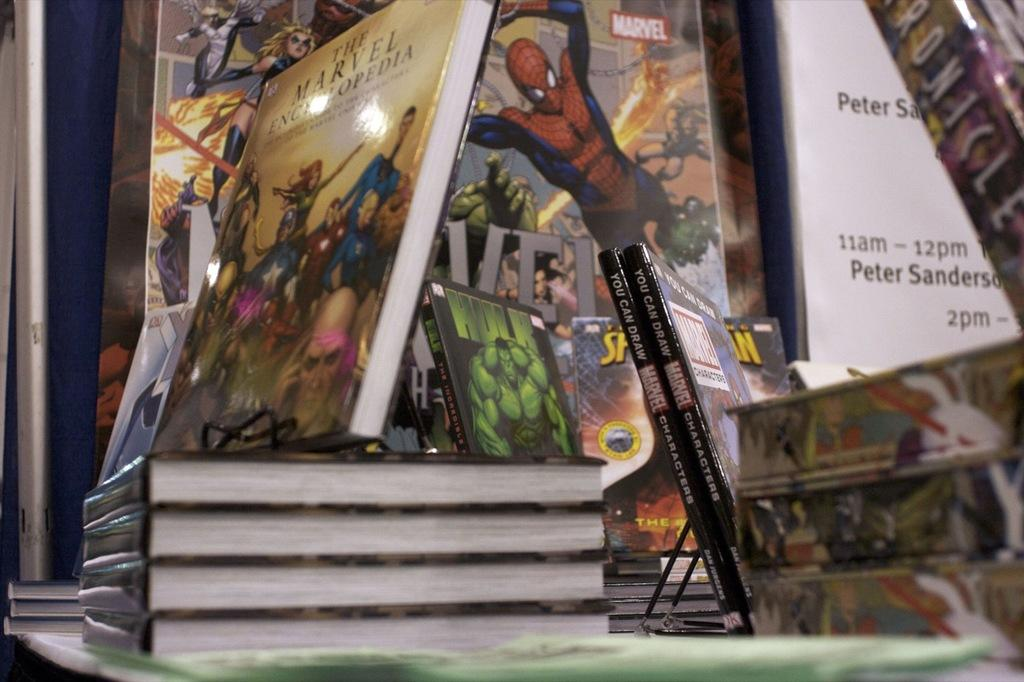Provide a one-sentence caption for the provided image. Different hardcover Marvel books are displayed on a table. 